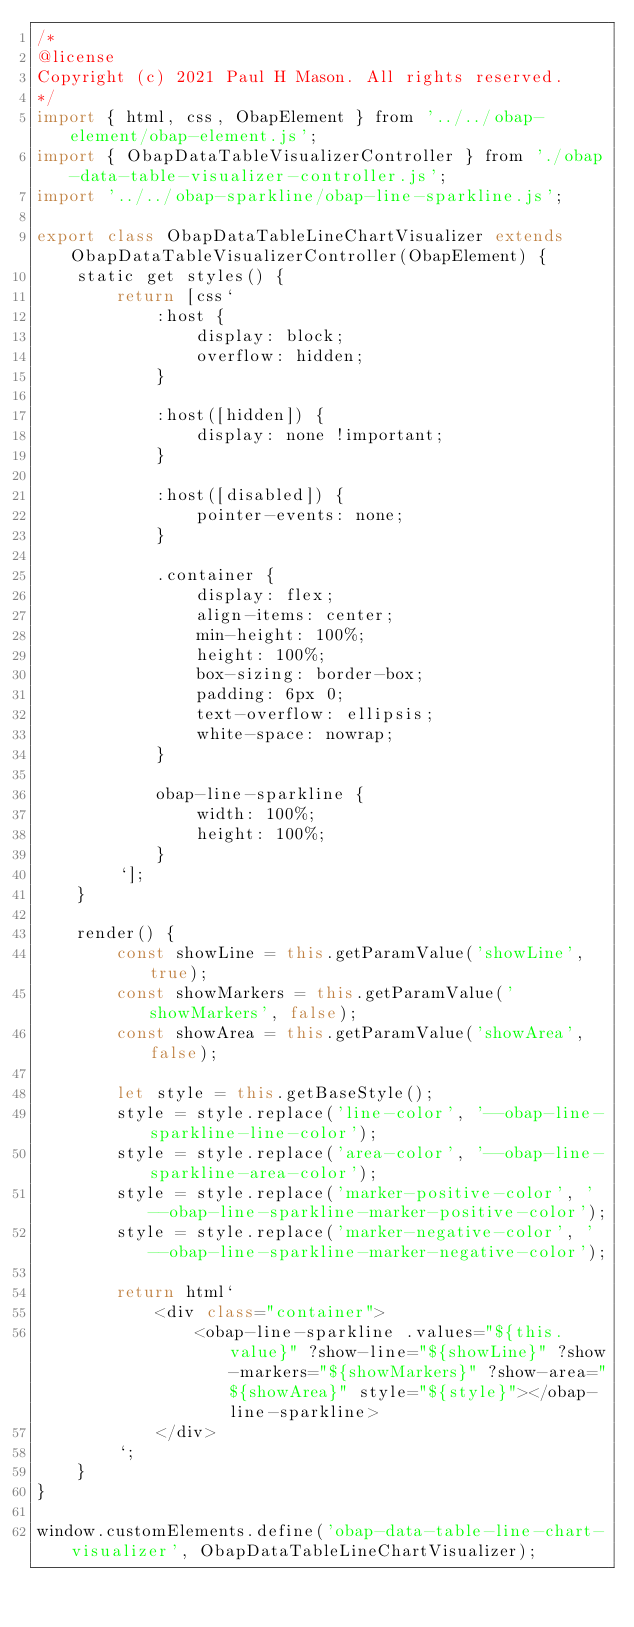<code> <loc_0><loc_0><loc_500><loc_500><_JavaScript_>/*
@license
Copyright (c) 2021 Paul H Mason. All rights reserved.
*/
import { html, css, ObapElement } from '../../obap-element/obap-element.js';
import { ObapDataTableVisualizerController } from './obap-data-table-visualizer-controller.js';
import '../../obap-sparkline/obap-line-sparkline.js';

export class ObapDataTableLineChartVisualizer extends ObapDataTableVisualizerController(ObapElement) {
    static get styles() {
        return [css`
            :host {
                display: block;
                overflow: hidden;
            }
    
            :host([hidden]) {
                display: none !important;
            }
    
            :host([disabled]) {
                pointer-events: none;
            }

            .container {
                display: flex;
                align-items: center;
                min-height: 100%;
                height: 100%;
                box-sizing: border-box;
                padding: 6px 0;
                text-overflow: ellipsis;
                white-space: nowrap;
            }

            obap-line-sparkline {
                width: 100%;
                height: 100%;
            }
        `];
    }

    render() {
        const showLine = this.getParamValue('showLine', true);
        const showMarkers = this.getParamValue('showMarkers', false);
        const showArea = this.getParamValue('showArea', false);

        let style = this.getBaseStyle();
        style = style.replace('line-color', '--obap-line-sparkline-line-color');
        style = style.replace('area-color', '--obap-line-sparkline-area-color');
        style = style.replace('marker-positive-color', '--obap-line-sparkline-marker-positive-color');
        style = style.replace('marker-negative-color', '--obap-line-sparkline-marker-negative-color');

        return html`
            <div class="container">
                <obap-line-sparkline .values="${this.value}" ?show-line="${showLine}" ?show-markers="${showMarkers}" ?show-area="${showArea}" style="${style}"></obap-line-sparkline>
            </div>
        `;
    }
}

window.customElements.define('obap-data-table-line-chart-visualizer', ObapDataTableLineChartVisualizer);
</code> 